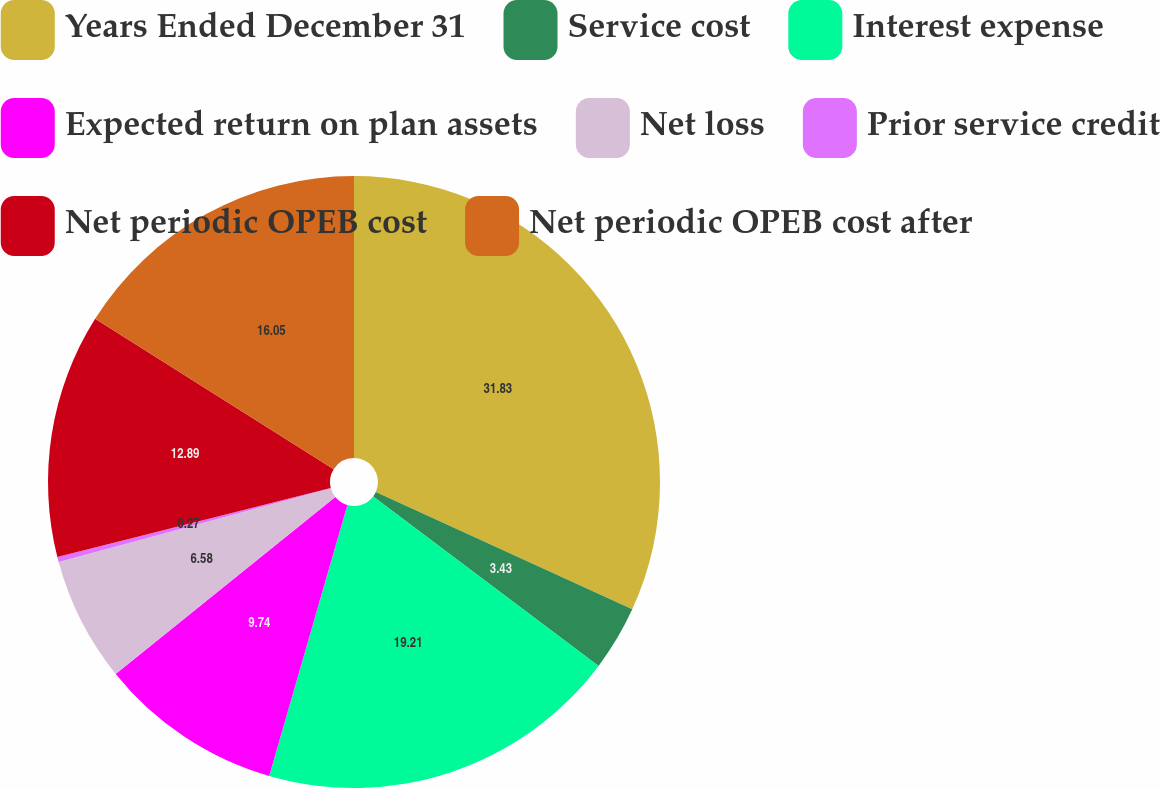Convert chart. <chart><loc_0><loc_0><loc_500><loc_500><pie_chart><fcel>Years Ended December 31<fcel>Service cost<fcel>Interest expense<fcel>Expected return on plan assets<fcel>Net loss<fcel>Prior service credit<fcel>Net periodic OPEB cost<fcel>Net periodic OPEB cost after<nl><fcel>31.83%<fcel>3.43%<fcel>19.21%<fcel>9.74%<fcel>6.58%<fcel>0.27%<fcel>12.89%<fcel>16.05%<nl></chart> 